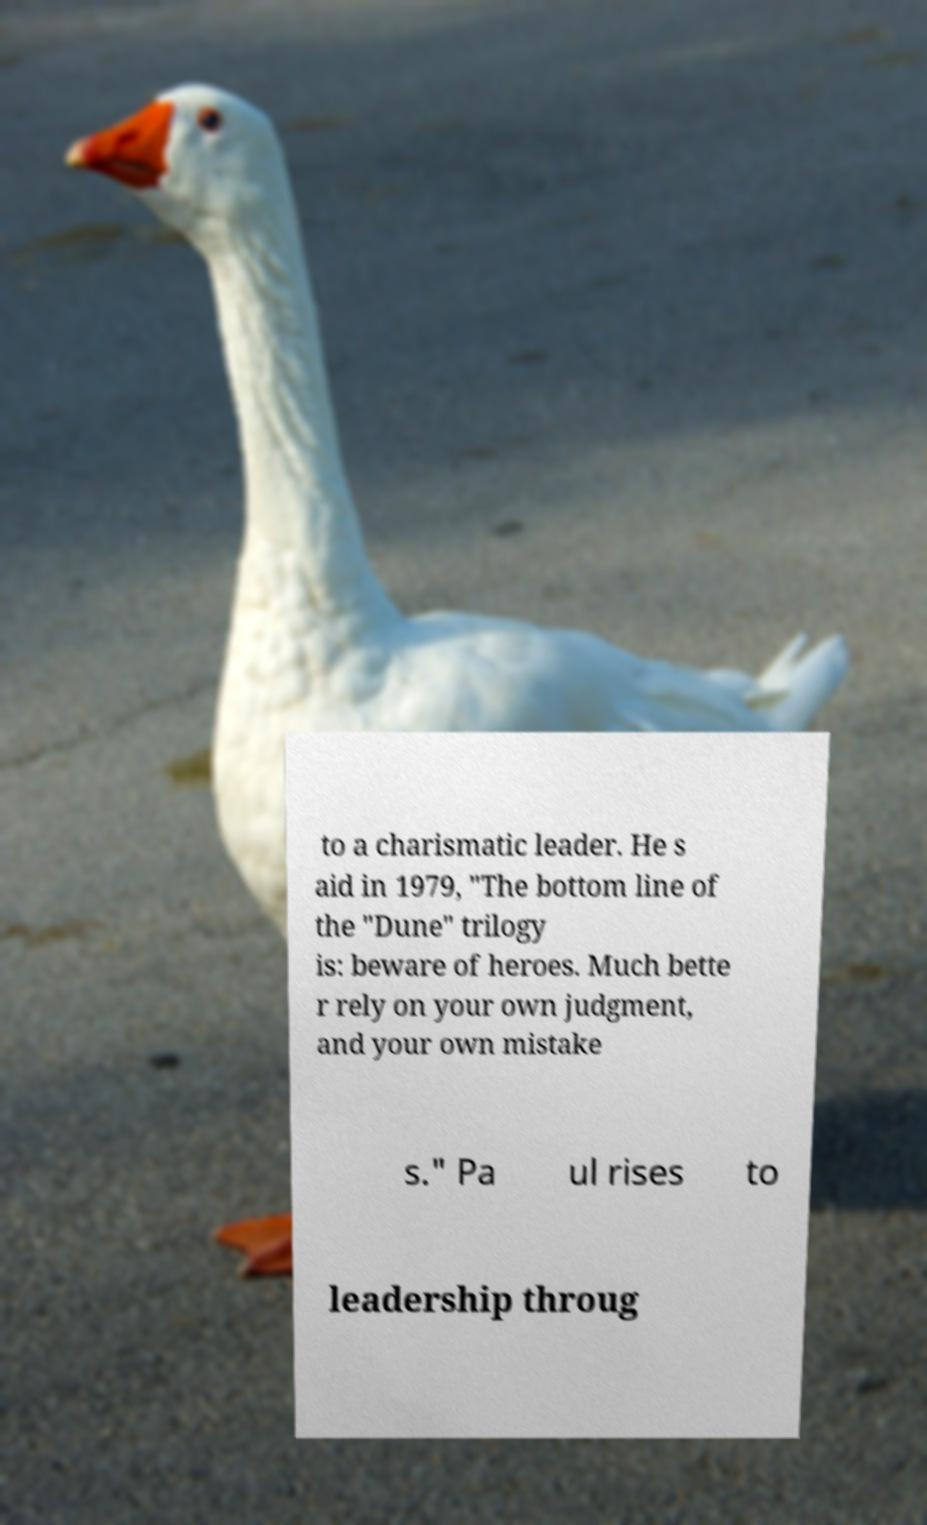Could you extract and type out the text from this image? to a charismatic leader. He s aid in 1979, "The bottom line of the "Dune" trilogy is: beware of heroes. Much bette r rely on your own judgment, and your own mistake s." Pa ul rises to leadership throug 